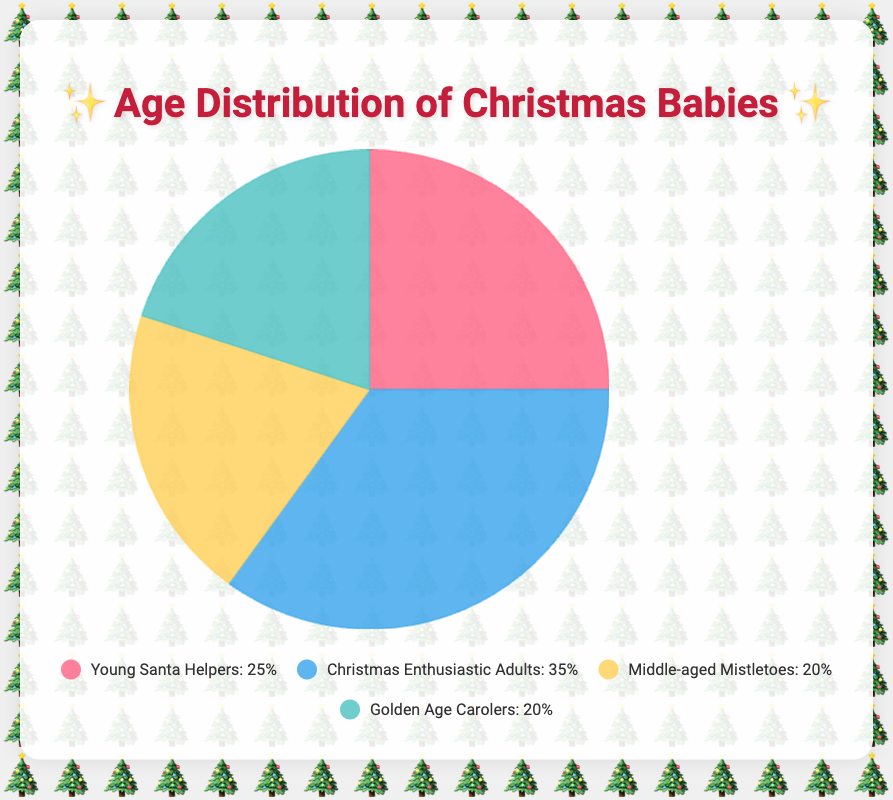What's the most common age range for people born on Christmas Day? The pie chart shows four age ranges. The largest section, by percentage, is 20-39, which represents 35%.
Answer: 20-39 Which age range represents the smallest percentage of people born on Christmas Day? The pie chart shows that the age ranges 40-59 and 60+ both represent 20%. Since these are the lowest percentages, they are the smallest.
Answer: 40-59 and 60+ How much more, in percentage points, do Christmas Enthusiastic Adults make up compared to Middle-aged Mistletoes? Christmas Enthusiastic Adults are 35% and Middle-aged Mistletoes are 20%. The difference is 35% - 20% = 15%.
Answer: 15% What is the total percentage of people either in the 0-19 or the 60+ age ranges? The pie chart shows 0-19 is 25% and 60+ is 20%. Adding these together gives 25% + 20% = 45%.
Answer: 45% What color represents the Golden Age Carolers on the chart? The legend indicates that Golden Age Carolers are represented by a greenish-blue color in the chart.
Answer: Greenish-blue Which age group has a percentage closest to the combined percentage of Middle-aged Mistletoes and Golden Age Carolers? Middle-aged Mistletoes are 20% and Golden Age Carolers are 20%. Combined, they are 20% + 20% = 40%. The closest group by percentage is Christmas Enthusiastic Adults with 35%.
Answer: Christmas Enthusiastic Adults If you combine the percentages of Young Santa Helpers and Christmas Enthusiastic Adults, how does this compare to the combined total of Middle-aged Mistletoes and Golden Age Carolers? Young Santa Helpers and Christmas Enthusiastic Adults together are 25% + 35% = 60%. Middle-aged Mistletoes and Golden Age Carolers together are 20% + 20% = 40%. 60% is greater than 40%.
Answer: 60% is greater than 40% What visual feature can help you quickly identify the largest age group in the chart? The sector size of the pie chart is the visual feature. The largest sector by size is 20-39, which is the largest age group.
Answer: Sector size 